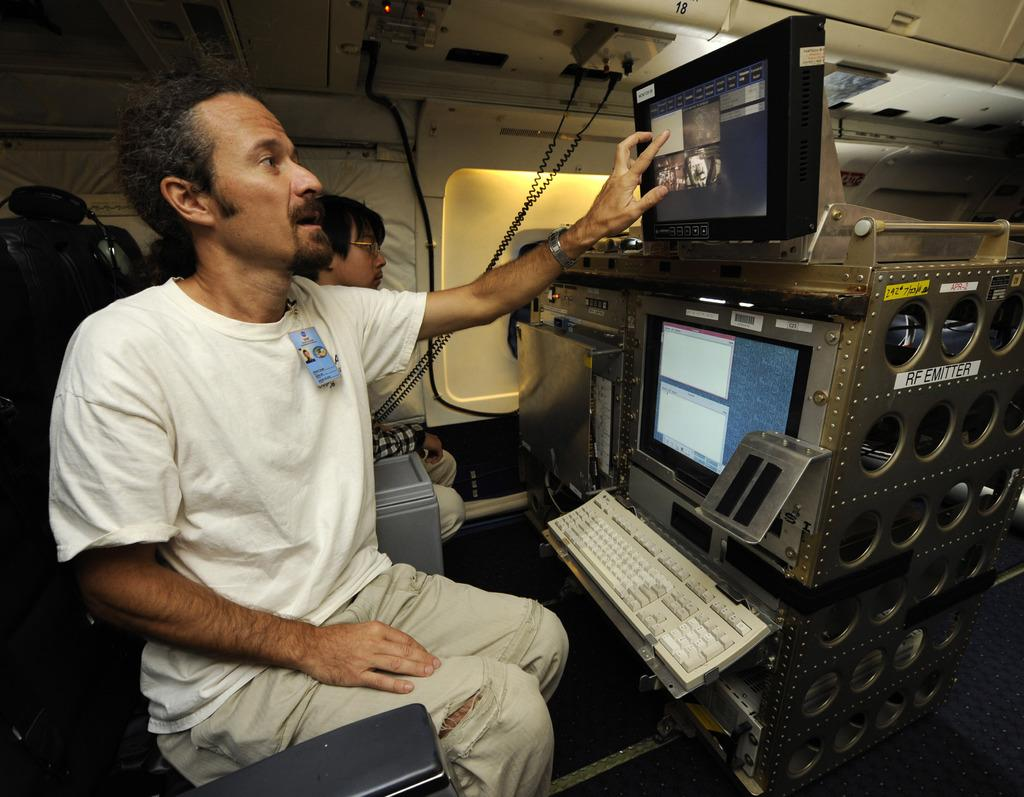<image>
Write a terse but informative summary of the picture. a man with a name tag next to a yellow sticker with 292 on it 